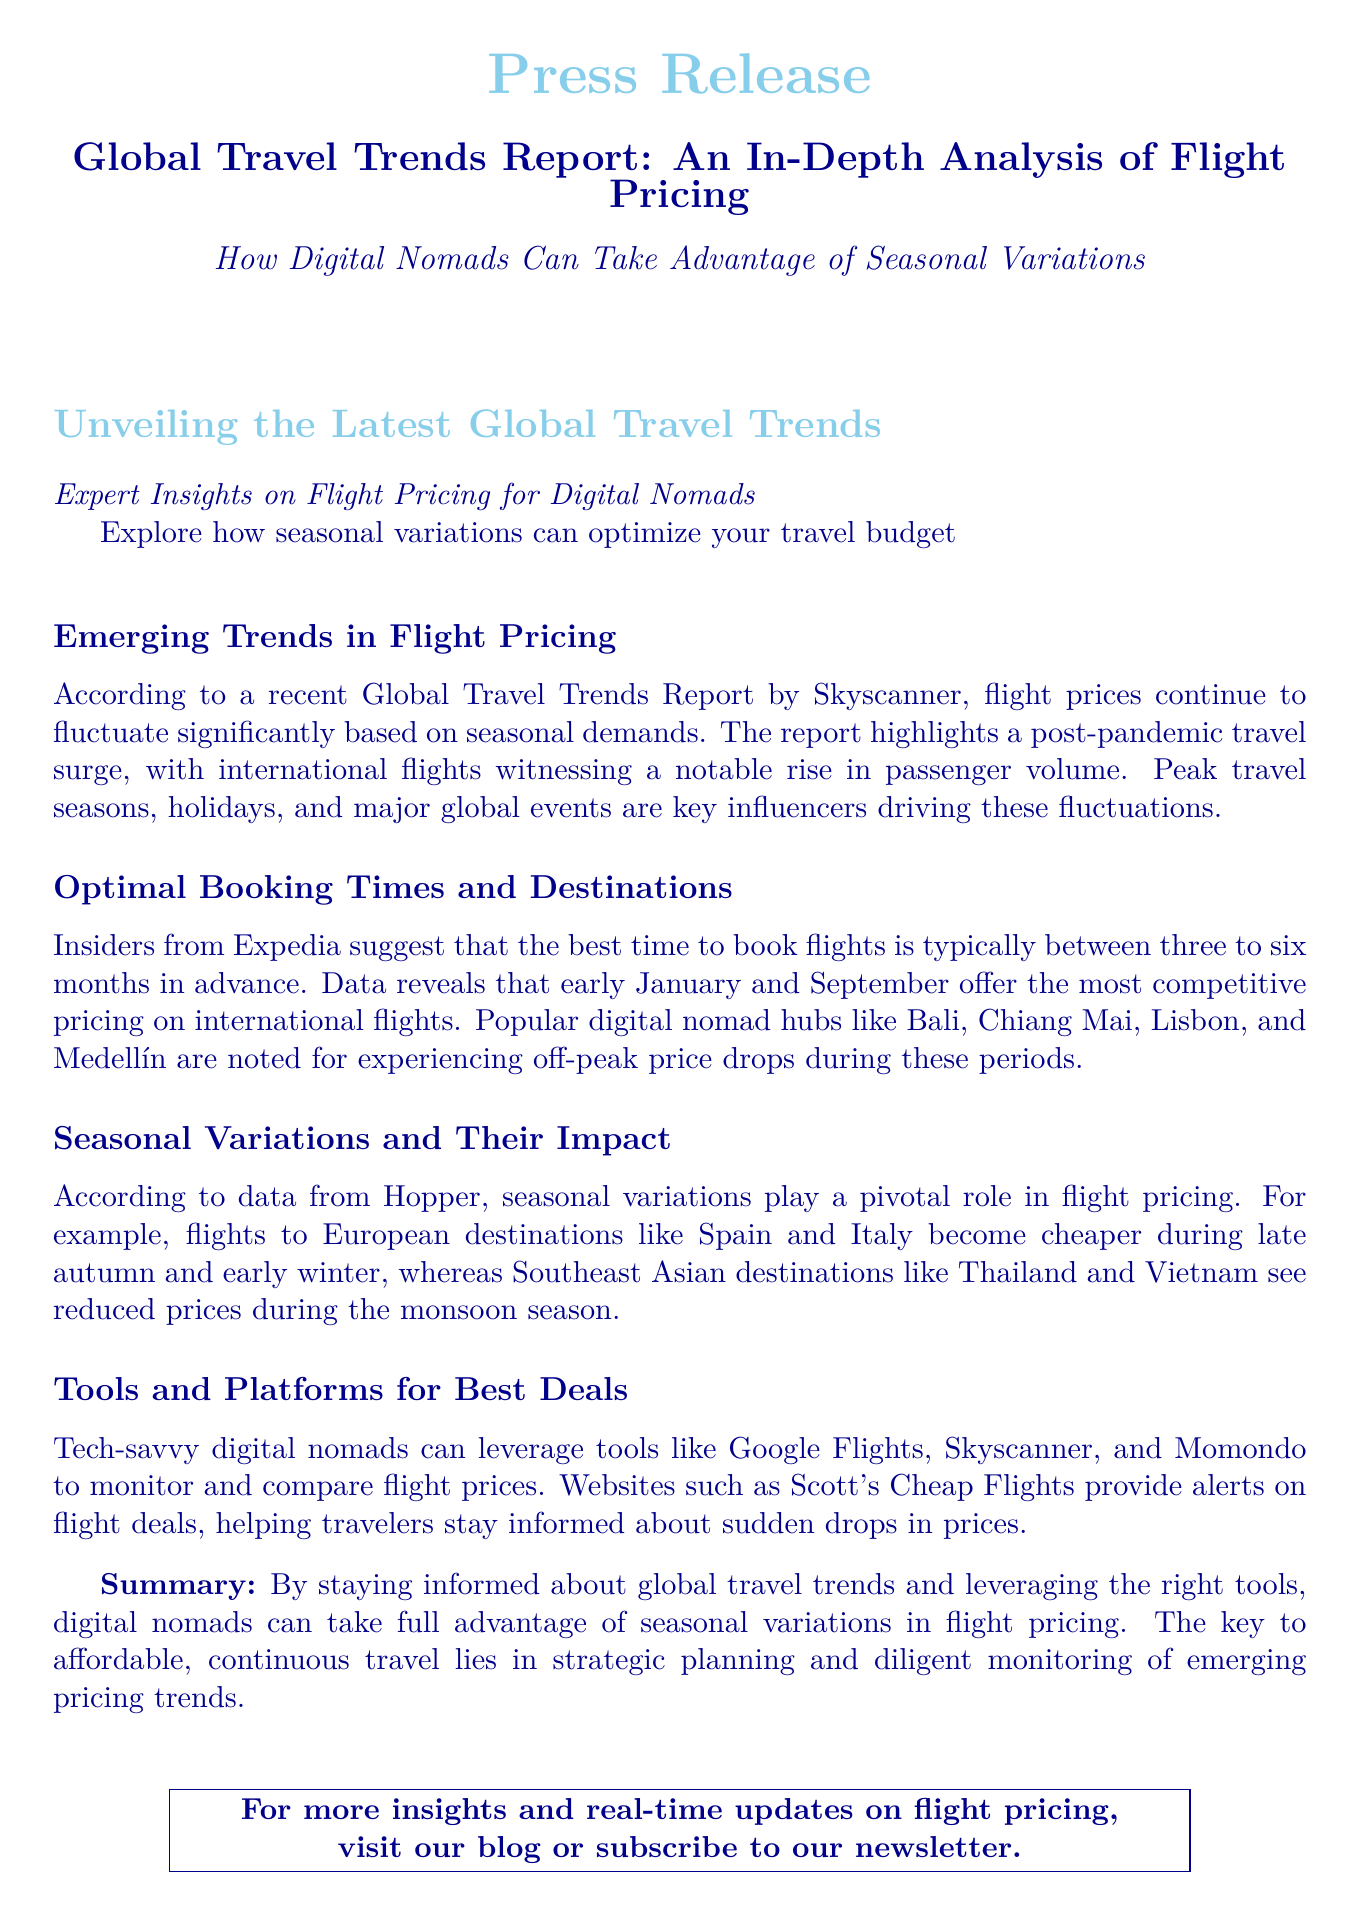What is the main focus of the press release? The press release focuses on analyzing flight pricing and how digital nomads can benefit from seasonal variations.
Answer: Flight pricing and seasonal variations What months are suggested as the best time to book flights? The report suggests that early January and September are optimal for booking flights.
Answer: Early January and September Which travel hub experiences price drops during off-peak periods? The document lists Bali, Chiang Mai, Lisbon, and Medellín as popular hubs for price drops.
Answer: Bali, Chiang Mai, Lisbon, Medellín What is the role of seasonal variations in flight pricing? Seasonal variations significantly influence flight pricing, with specific destinations seeing price changes during certain seasons.
Answer: Significant influence What tools can digital nomads use to monitor flight prices? The document mentions Google Flights, Skyscanner, and Momondo as effective tools for monitoring prices.
Answer: Google Flights, Skyscanner, Momondo How far in advance should flights be booked for the best deals? The report indicates that flights should be booked three to six months in advance for optimal pricing.
Answer: Three to six months Which countries have cheaper flights during late autumn? Spain and Italy are noted as countries where flights become cheaper during late autumn.
Answer: Spain and Italy What is the primary conclusion of the report? The conclusion emphasizes that strategic planning and monitoring trends can help digital nomads travel affordably.
Answer: Strategic planning and monitoring trends What does the report suggest about off-peak price reductions? The report highlights that off-peak price reductions significantly benefit digital nomads traveling during these times.
Answer: Benefit digital nomads 